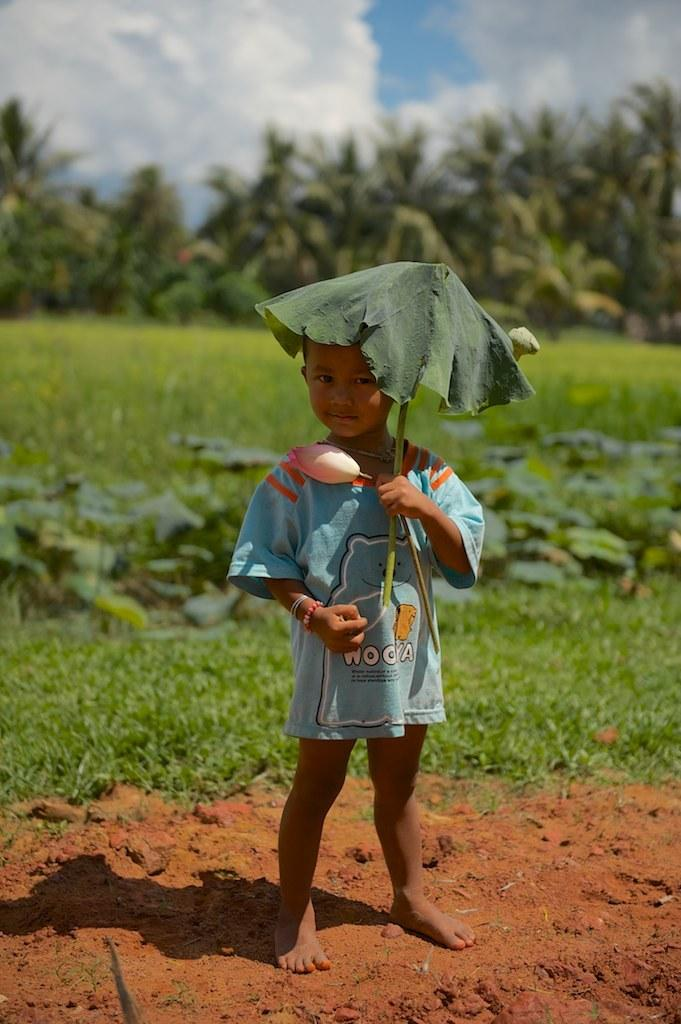What is the main subject of the image? There is a kid in the image. What is the kid holding in the image? The kid is holding a flower. Can you describe the plant in the image? There is a plant in the image, but no specific details are provided. What can be seen in the background of the image? There are plants, grass, and trees visible in the background of the image. How would you describe the weather in the image? The sky is cloudy in the image, suggesting a potentially overcast or rainy day. What type of game is the kid playing in the image? There is no game being played in the image; the kid is holding a flower. What word is written on the tree in the image? There is no word written on any tree in the image; the trees are simply part of the background. 